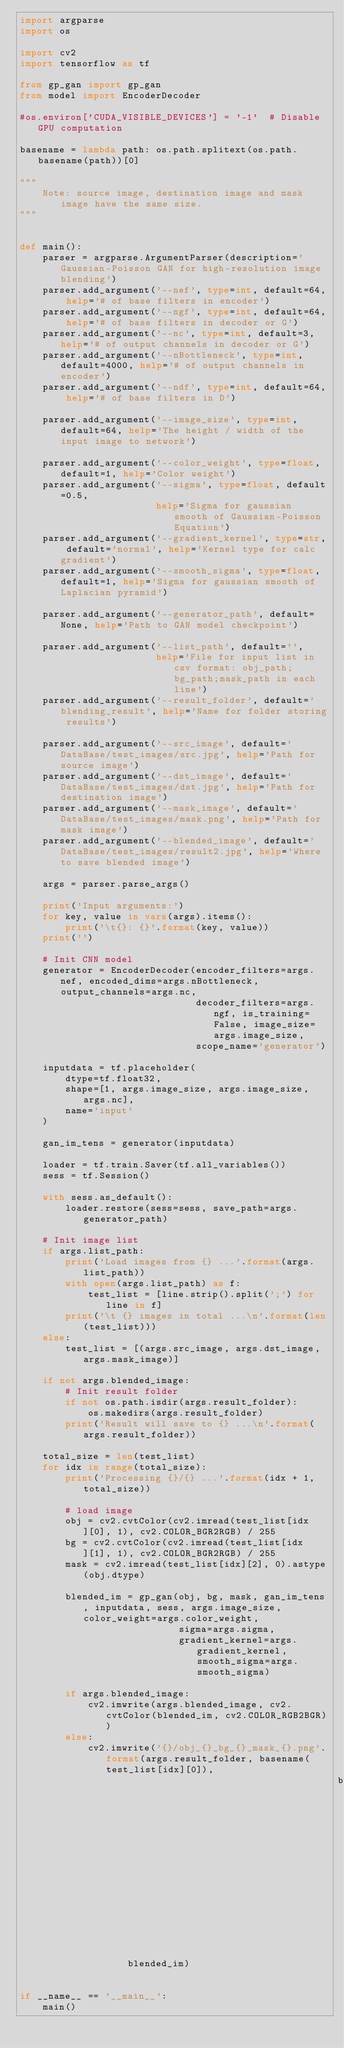Convert code to text. <code><loc_0><loc_0><loc_500><loc_500><_Python_>import argparse
import os

import cv2
import tensorflow as tf

from gp_gan import gp_gan
from model import EncoderDecoder

#os.environ['CUDA_VISIBLE_DEVICES'] = '-1'  # Disable GPU computation

basename = lambda path: os.path.splitext(os.path.basename(path))[0]

"""
    Note: source image, destination image and mask image have the same size.
"""


def main():
    parser = argparse.ArgumentParser(description='Gaussian-Poisson GAN for high-resolution image blending')
    parser.add_argument('--nef', type=int, default=64, help='# of base filters in encoder')
    parser.add_argument('--ngf', type=int, default=64, help='# of base filters in decoder or G')
    parser.add_argument('--nc', type=int, default=3, help='# of output channels in decoder or G')
    parser.add_argument('--nBottleneck', type=int, default=4000, help='# of output channels in encoder')
    parser.add_argument('--ndf', type=int, default=64, help='# of base filters in D')

    parser.add_argument('--image_size', type=int, default=64, help='The height / width of the input image to network')

    parser.add_argument('--color_weight', type=float, default=1, help='Color weight')
    parser.add_argument('--sigma', type=float, default=0.5,
                        help='Sigma for gaussian smooth of Gaussian-Poisson Equation')
    parser.add_argument('--gradient_kernel', type=str, default='normal', help='Kernel type for calc gradient')
    parser.add_argument('--smooth_sigma', type=float, default=1, help='Sigma for gaussian smooth of Laplacian pyramid')

    parser.add_argument('--generator_path', default=None, help='Path to GAN model checkpoint')

    parser.add_argument('--list_path', default='',
                        help='File for input list in csv format: obj_path;bg_path;mask_path in each line')
    parser.add_argument('--result_folder', default='blending_result', help='Name for folder storing results')

    parser.add_argument('--src_image', default='DataBase/test_images/src.jpg', help='Path for source image')
    parser.add_argument('--dst_image', default='DataBase/test_images/dst.jpg', help='Path for destination image')
    parser.add_argument('--mask_image', default='DataBase/test_images/mask.png', help='Path for mask image')
    parser.add_argument('--blended_image', default='DataBase/test_images/result2.jpg', help='Where to save blended image')

    args = parser.parse_args()

    print('Input arguments:')
    for key, value in vars(args).items():
        print('\t{}: {}'.format(key, value))
    print('')

    # Init CNN model
    generator = EncoderDecoder(encoder_filters=args.nef, encoded_dims=args.nBottleneck, output_channels=args.nc,
                               decoder_filters=args.ngf, is_training=False, image_size=args.image_size,
                               scope_name='generator')

    inputdata = tf.placeholder(
        dtype=tf.float32,
        shape=[1, args.image_size, args.image_size, args.nc],
        name='input'
    )

    gan_im_tens = generator(inputdata)

    loader = tf.train.Saver(tf.all_variables())
    sess = tf.Session()

    with sess.as_default():
        loader.restore(sess=sess, save_path=args.generator_path)

    # Init image list
    if args.list_path:
        print('Load images from {} ...'.format(args.list_path))
        with open(args.list_path) as f:
            test_list = [line.strip().split(';') for line in f]
        print('\t {} images in total ...\n'.format(len(test_list)))
    else:
        test_list = [(args.src_image, args.dst_image, args.mask_image)]

    if not args.blended_image:
        # Init result folder
        if not os.path.isdir(args.result_folder):
            os.makedirs(args.result_folder)
        print('Result will save to {} ...\n'.format(args.result_folder))

    total_size = len(test_list)
    for idx in range(total_size):
        print('Processing {}/{} ...'.format(idx + 1, total_size))

        # load image
        obj = cv2.cvtColor(cv2.imread(test_list[idx][0], 1), cv2.COLOR_BGR2RGB) / 255
        bg = cv2.cvtColor(cv2.imread(test_list[idx][1], 1), cv2.COLOR_BGR2RGB) / 255
        mask = cv2.imread(test_list[idx][2], 0).astype(obj.dtype)

        blended_im = gp_gan(obj, bg, mask, gan_im_tens, inputdata, sess, args.image_size, color_weight=args.color_weight,
                            sigma=args.sigma,
                            gradient_kernel=args.gradient_kernel, smooth_sigma=args.smooth_sigma)

        if args.blended_image:
            cv2.imwrite(args.blended_image, cv2.cvtColor(blended_im, cv2.COLOR_RGB2BGR))
        else:
            cv2.imwrite('{}/obj_{}_bg_{}_mask_{}.png'.format(args.result_folder, basename(test_list[idx][0]),
                                                        basename(test_list[idx][1]), basename(test_list[idx][2])),
                   blended_im)


if __name__ == '__main__':
    main()
</code> 